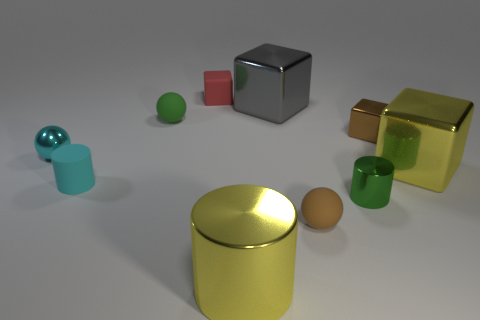Subtract all cylinders. How many objects are left? 7 Add 7 red things. How many red things are left? 8 Add 1 big brown balls. How many big brown balls exist? 1 Subtract 0 blue spheres. How many objects are left? 10 Subtract all rubber cylinders. Subtract all large brown matte cylinders. How many objects are left? 9 